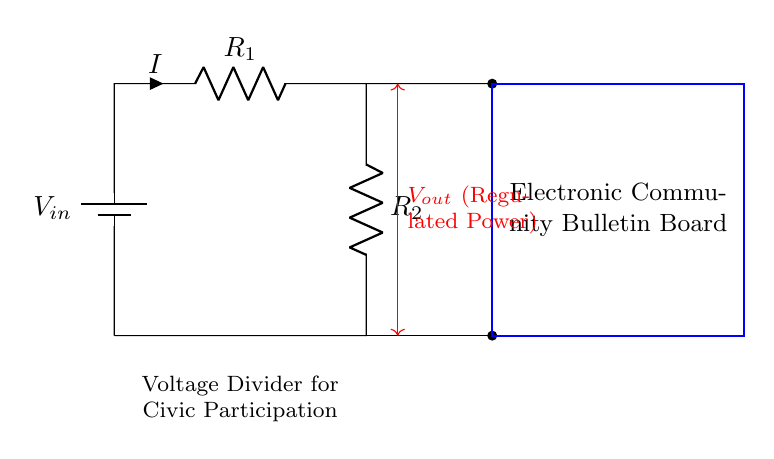What is the input voltage in the circuit? The input voltage is labeled as V_in at the battery. In the circuit diagram, the battery provides the power source for the entire circuit.
Answer: V_in What are the resistances in the circuit? The circuit has two resistors: R_1 and R_2. They are connected in series as part of the voltage divider configuration. The labels next to them indicate their respective roles.
Answer: R_1 and R_2 What is the current flowing through the resistors? The current, labeled as I in the circuit diagram, flows through R_1 and R_2 since they are in series. The value of I is not specified in the circuit; it's a variable.
Answer: I What is the purpose of the electronic community bulletin board? The purpose is indicated in the labeled rectangle; it shows that this component is meant for local civic participation and information sharing. It receives the regulated power from the voltage divider.
Answer: To foster local civic participation How is V_out regulated in the circuit? V_out is regulated by the voltage divider effect. The voltage drop across R_2 provides the regulated output voltage for the electronic community bulletin board. The ratio of the resistances determines the resultant voltage.
Answer: By the voltage divider What does the red arrow represent in the circuit? The red arrow indicates the regulated output voltage, V_out, which is the voltage available to the electronic community bulletin board from the voltage divider configuration.
Answer: V_out (Regulated Power) What is the functional relationship between R_1 and R_2? The resistors R_1 and R_2 in series create a voltage divider. The output voltage is a fraction of the input voltage determined by the ratio of R_1 to R_2, affecting how much voltage is allocated to the bulletin board.
Answer: They form a voltage divider 